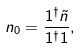Convert formula to latex. <formula><loc_0><loc_0><loc_500><loc_500>n _ { 0 } = \frac { { 1 } ^ { \dagger } \tilde { n } } { { 1 } ^ { \dagger } { 1 } } ,</formula> 